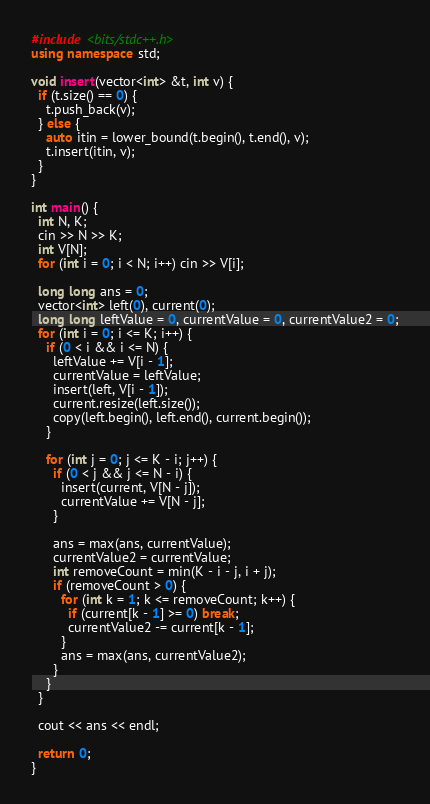<code> <loc_0><loc_0><loc_500><loc_500><_C++_>#include <bits/stdc++.h>
using namespace std;

void insert(vector<int> &t, int v) {
  if (t.size() == 0) {
    t.push_back(v);
  } else {
    auto itin = lower_bound(t.begin(), t.end(), v);
    t.insert(itin, v);
  }
}

int main() {
  int N, K;
  cin >> N >> K;
  int V[N];
  for (int i = 0; i < N; i++) cin >> V[i];

  long long ans = 0;
  vector<int> left(0), current(0);
  long long leftValue = 0, currentValue = 0, currentValue2 = 0;
  for (int i = 0; i <= K; i++) {
    if (0 < i && i <= N) {
      leftValue += V[i - 1];
      currentValue = leftValue;
      insert(left, V[i - 1]);
      current.resize(left.size());
      copy(left.begin(), left.end(), current.begin());
    }

    for (int j = 0; j <= K - i; j++) {
      if (0 < j && j <= N - i) {
        insert(current, V[N - j]);
        currentValue += V[N - j];
      }

      ans = max(ans, currentValue);
      currentValue2 = currentValue;
      int removeCount = min(K - i - j, i + j);
      if (removeCount > 0) {
        for (int k = 1; k <= removeCount; k++) {
          if (current[k - 1] >= 0) break;
          currentValue2 -= current[k - 1];
        }
        ans = max(ans, currentValue2);
      }
    }
  }

  cout << ans << endl;

  return 0;
}
</code> 